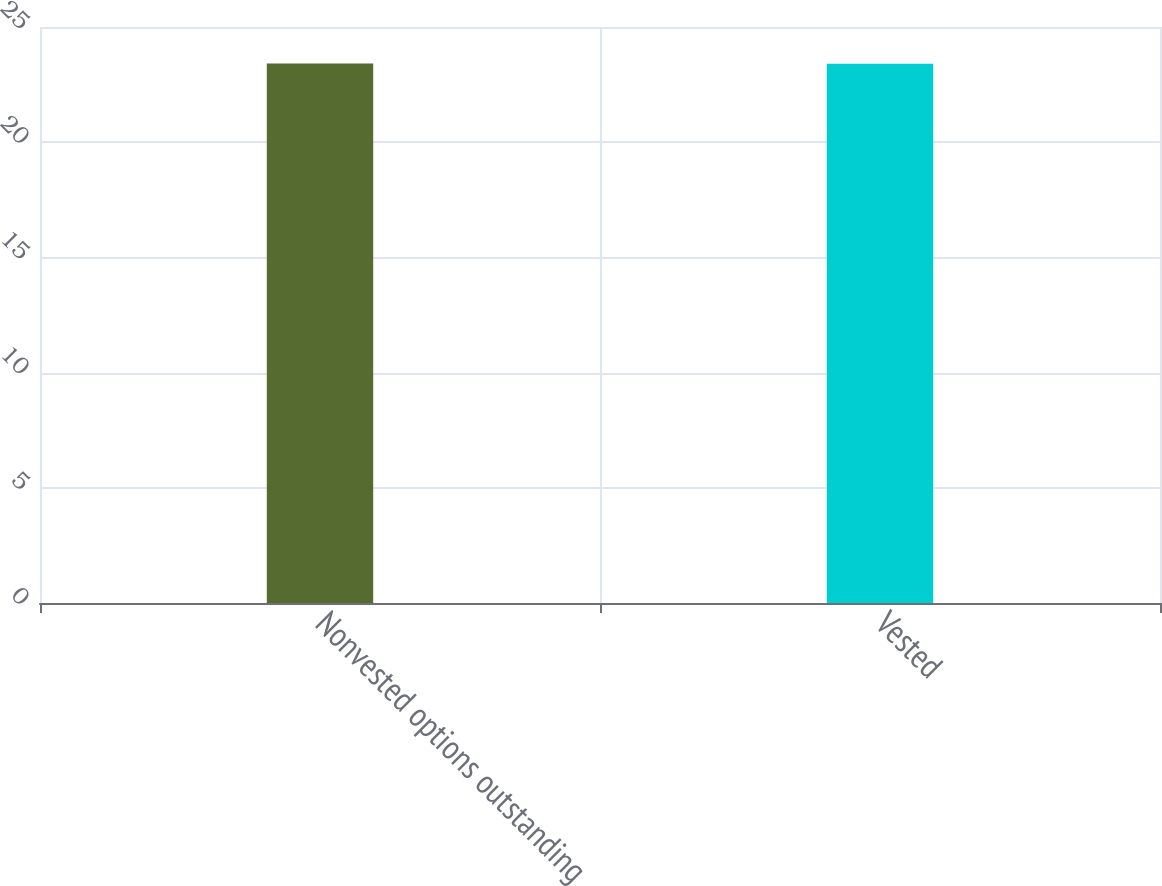<chart> <loc_0><loc_0><loc_500><loc_500><bar_chart><fcel>Nonvested options outstanding<fcel>Vested<nl><fcel>23.42<fcel>23.4<nl></chart> 